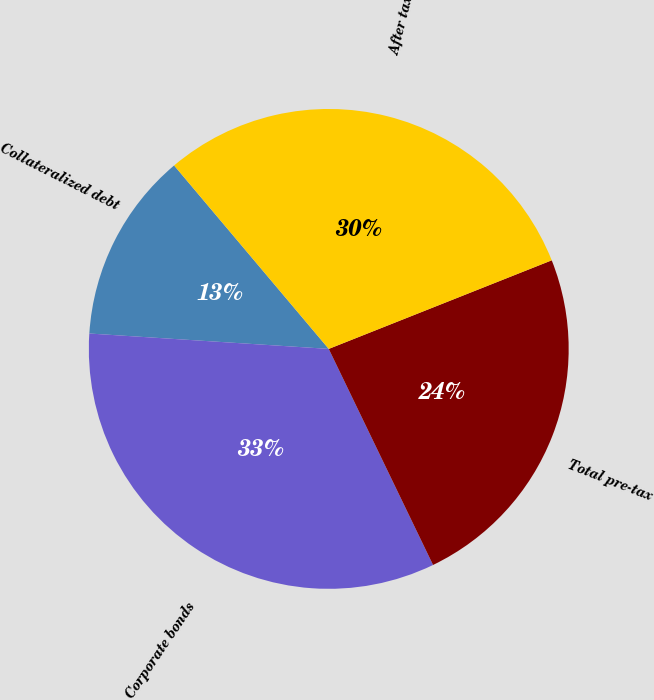Convert chart to OTSL. <chart><loc_0><loc_0><loc_500><loc_500><pie_chart><fcel>Collateralized debt<fcel>Corporate bonds<fcel>Total pre-tax<fcel>After tax<nl><fcel>12.83%<fcel>33.18%<fcel>23.86%<fcel>30.13%<nl></chart> 